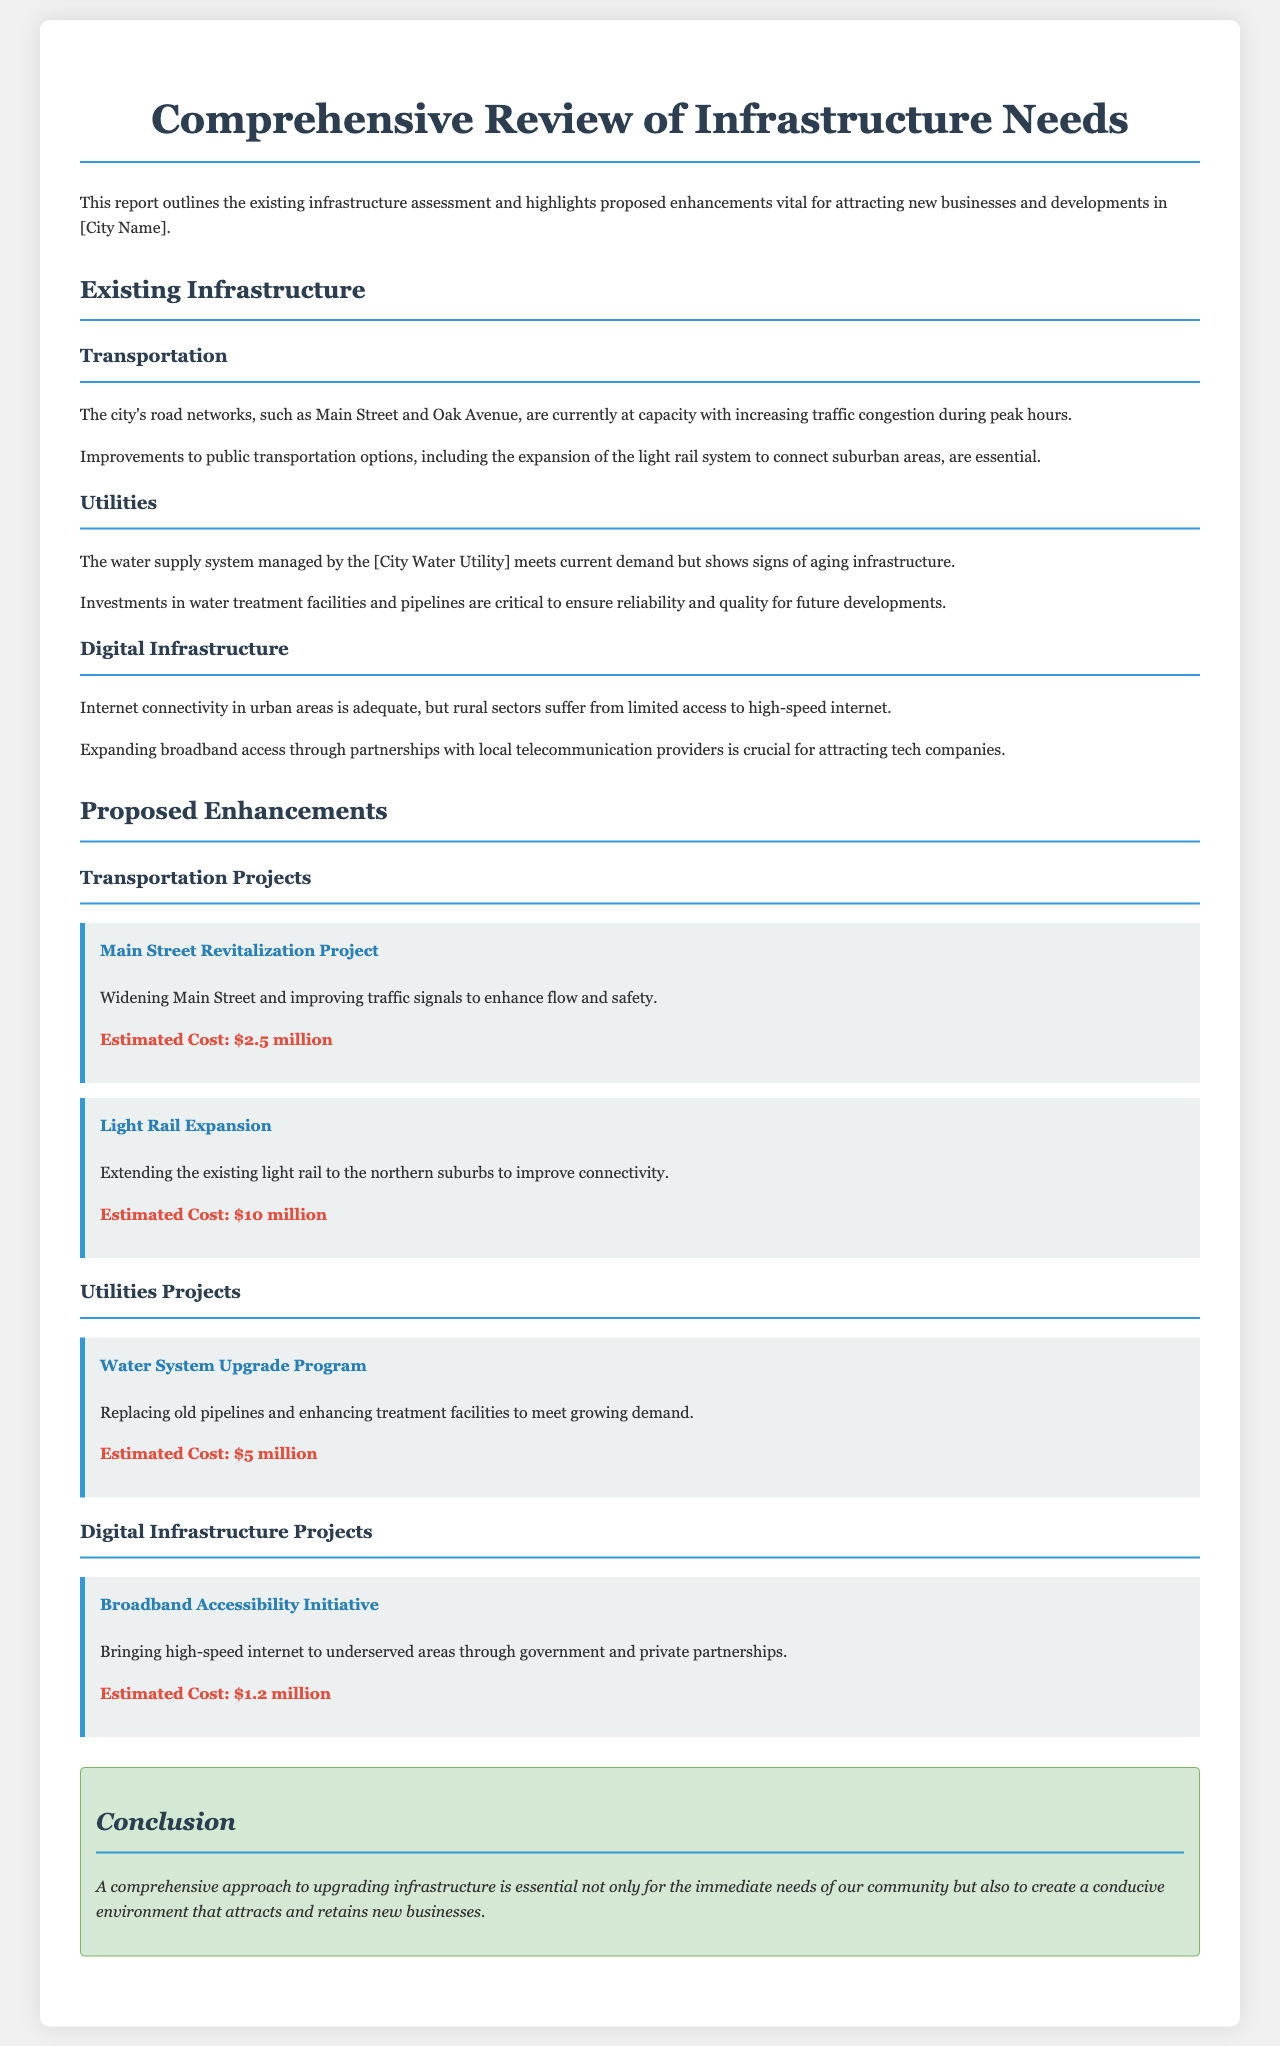What are the current traffic conditions on Main Street? The document states that the city's road networks, such as Main Street, are currently at capacity with increasing traffic congestion during peak hours.
Answer: At capacity What is the estimated cost of the Light Rail Expansion project? The document specifies that the estimated cost of the Light Rail Expansion is $10 million.
Answer: $10 million What is the purpose of the Water System Upgrade Program? The document mentions that the purpose of the Water System Upgrade Program is to replace old pipelines and enhance treatment facilities to meet growing demand.
Answer: Replace old pipelines How much is needed for the Broadband Accessibility Initiative? The document indicates that the estimated cost for the Broadband Accessibility Initiative is $1.2 million.
Answer: $1.2 million What kind of improvements are suggested for digital infrastructure? The report highlights that expanding broadband access through partnerships with local telecommunication providers is crucial for attracting tech companies.
Answer: Expanding broadband access How many transportation projects are proposed in the document? The document lists two transportation projects: Main Street Revitalization Project and Light Rail Expansion.
Answer: Two What does the conclusion emphasize regarding infrastructure upgrades? The conclusion underscores that a comprehensive approach to upgrading infrastructure is essential for attracting and retaining new businesses.
Answer: Attracting new businesses Which utility's water supply system is mentioned in the report? The document refers to the water supply system managed by the [City Water Utility].
Answer: [City Water Utility] 